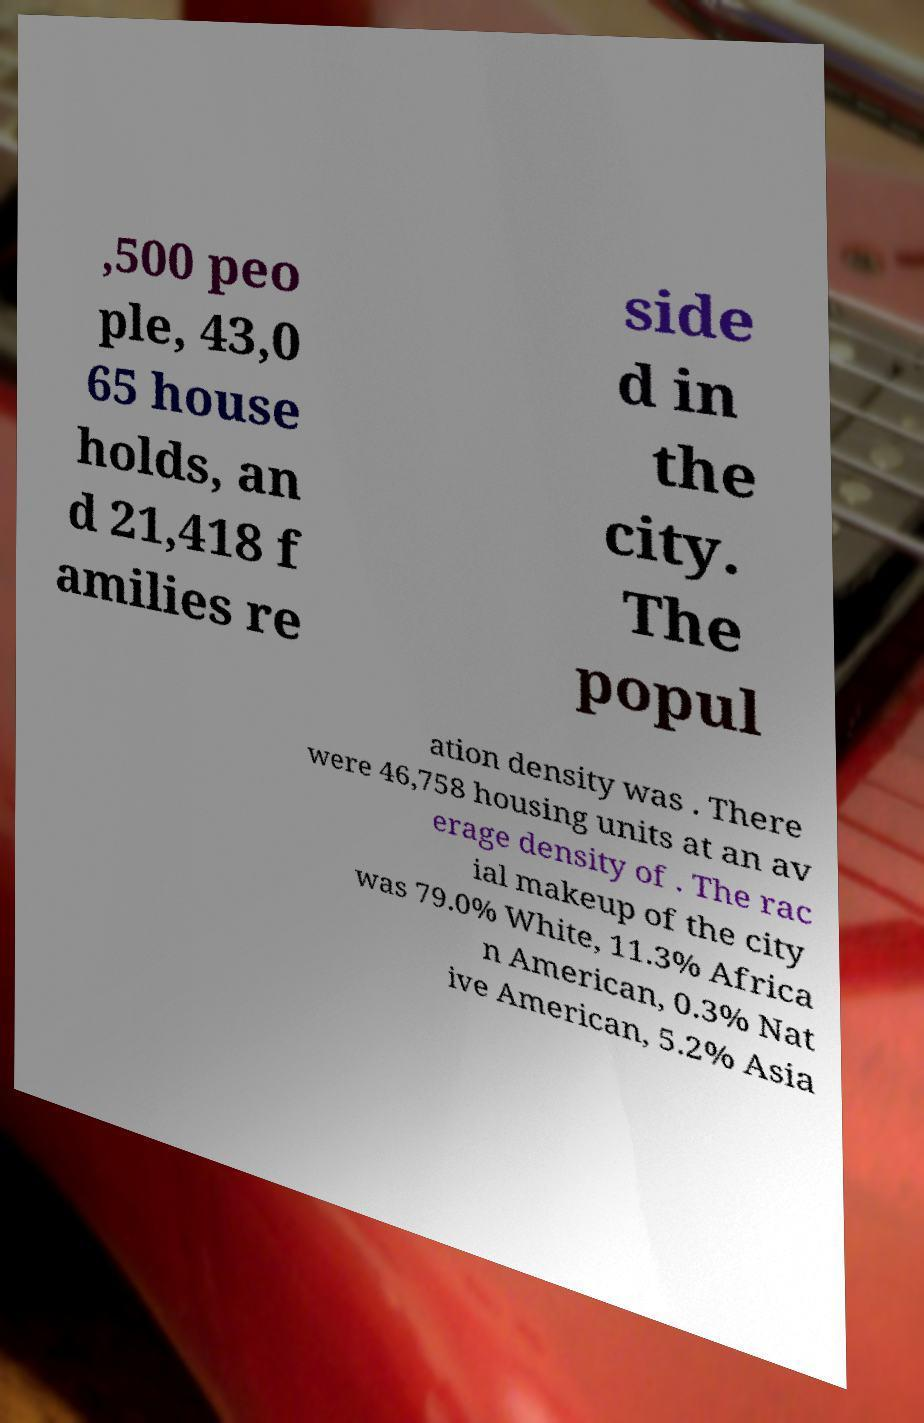Could you assist in decoding the text presented in this image and type it out clearly? ,500 peo ple, 43,0 65 house holds, an d 21,418 f amilies re side d in the city. The popul ation density was . There were 46,758 housing units at an av erage density of . The rac ial makeup of the city was 79.0% White, 11.3% Africa n American, 0.3% Nat ive American, 5.2% Asia 